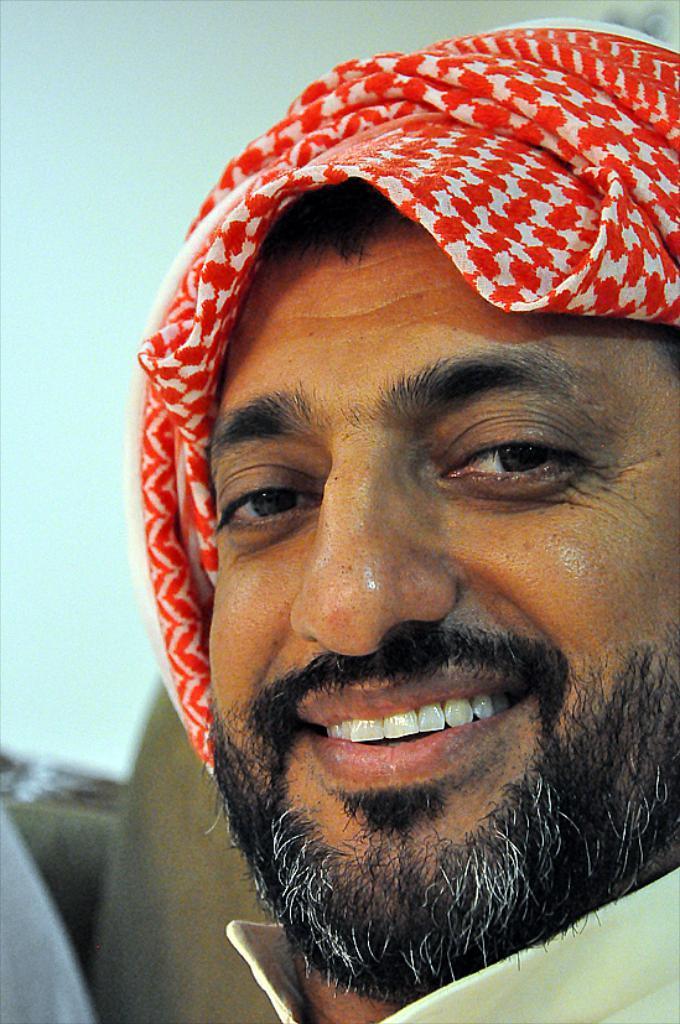Describe this image in one or two sentences. Here I can see a man wearing a red color head scarf, smiling and looking at the picture. In the background there is a wall. 